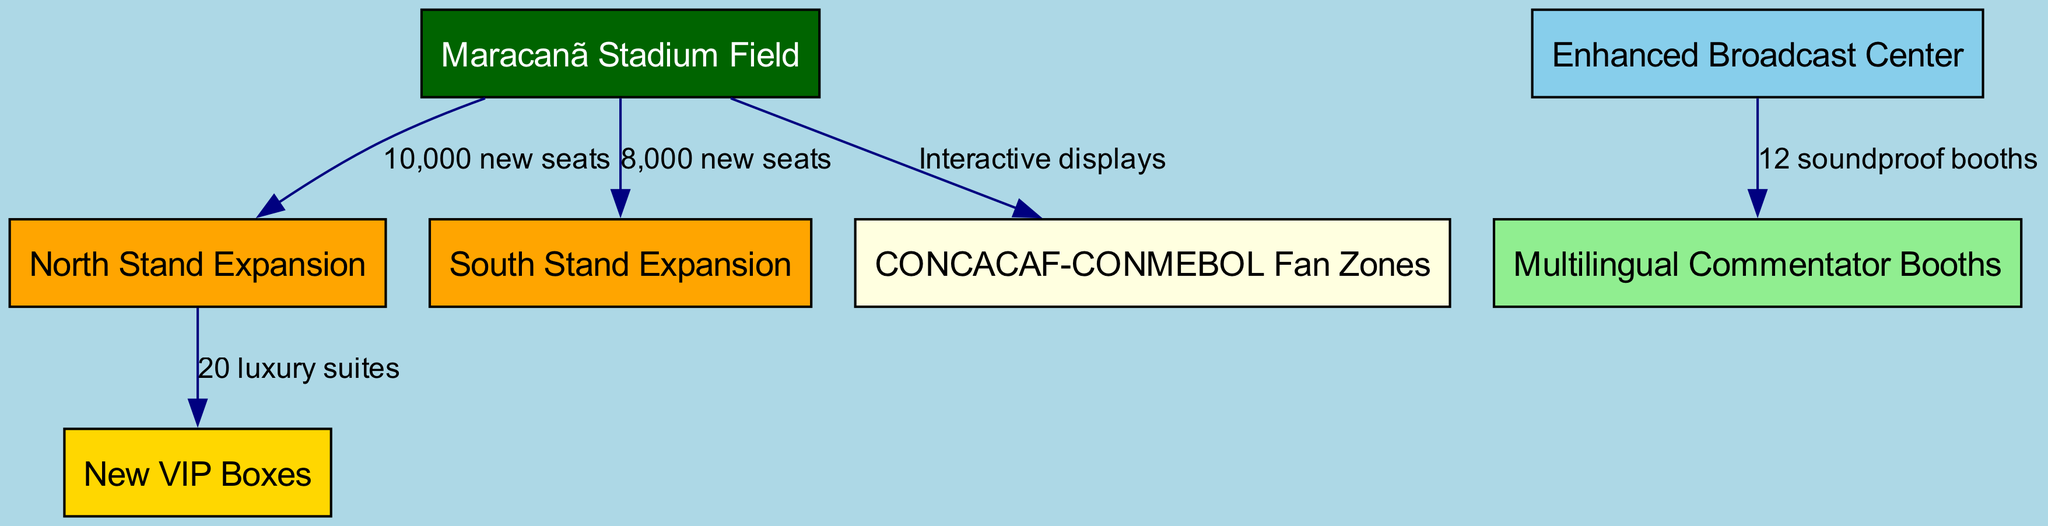What are the new seating numbers in the North Stand? The diagram shows an edge from the Maracanã Stadium Field to the North Stand Expansion with a label that states "10,000 new seats," which indicates the number of additional seats in that section.
Answer: 10,000 new seats What is the total number of new seats added in the stadium? To find the total new seating, we need to sum the new seats in the North Stand and South Stand. The North Stand has 10,000 new seats, and the South Stand has 8,000 new seats. Adding these numbers gives 10,000 + 8,000 = 18,000.
Answer: 18,000 How many luxury suites are in the new VIP Boxes? The diagram shows a connection from the North Stand Expansion to the New VIP Boxes, labeled with "20 luxury suites," which directly indicates the number of suites available.
Answer: 20 luxury suites What type of booths are included in the Enhanced Broadcast Center? The Enhanced Broadcast Center connects to the Multilingual Commentator Booths with an edge labeled "12 soundproof booths," which specifies the type of booths being added.
Answer: 12 soundproof booths What type of interaction is featured in the CONCACAF-CONMEBOL Fan Zones? The diagram indicates that from the main field, there is a connection to the Fan Zones labeled "Interactive displays," outlining the nature of the interaction in that area.
Answer: Interactive displays Which stand has more new seating, North or South? By examining the diagram, the North Stand Expansion has 10,000 new seats, while the South Stand Expansion has 8,000 new seats. Therefore, comparing these values shows the North Stand has more seating.
Answer: North Stand What is the purpose of the connection between the broadcast center and the commentator booths? The connection indicates that the Enhanced Broadcast Center is designed to support the Multilingual Commentator Booths with "12 soundproof booths," emphasizing the purpose of providing a professional environment for commentators.
Answer: Support for commentators How many fan zones are mentioned in the diagram? The diagram specifically notes one connection leading to the CONCACAF-CONMEBOL Fan Zones, implying that there is a singular designation for this feature in the stadium expansion.
Answer: One fan zone 